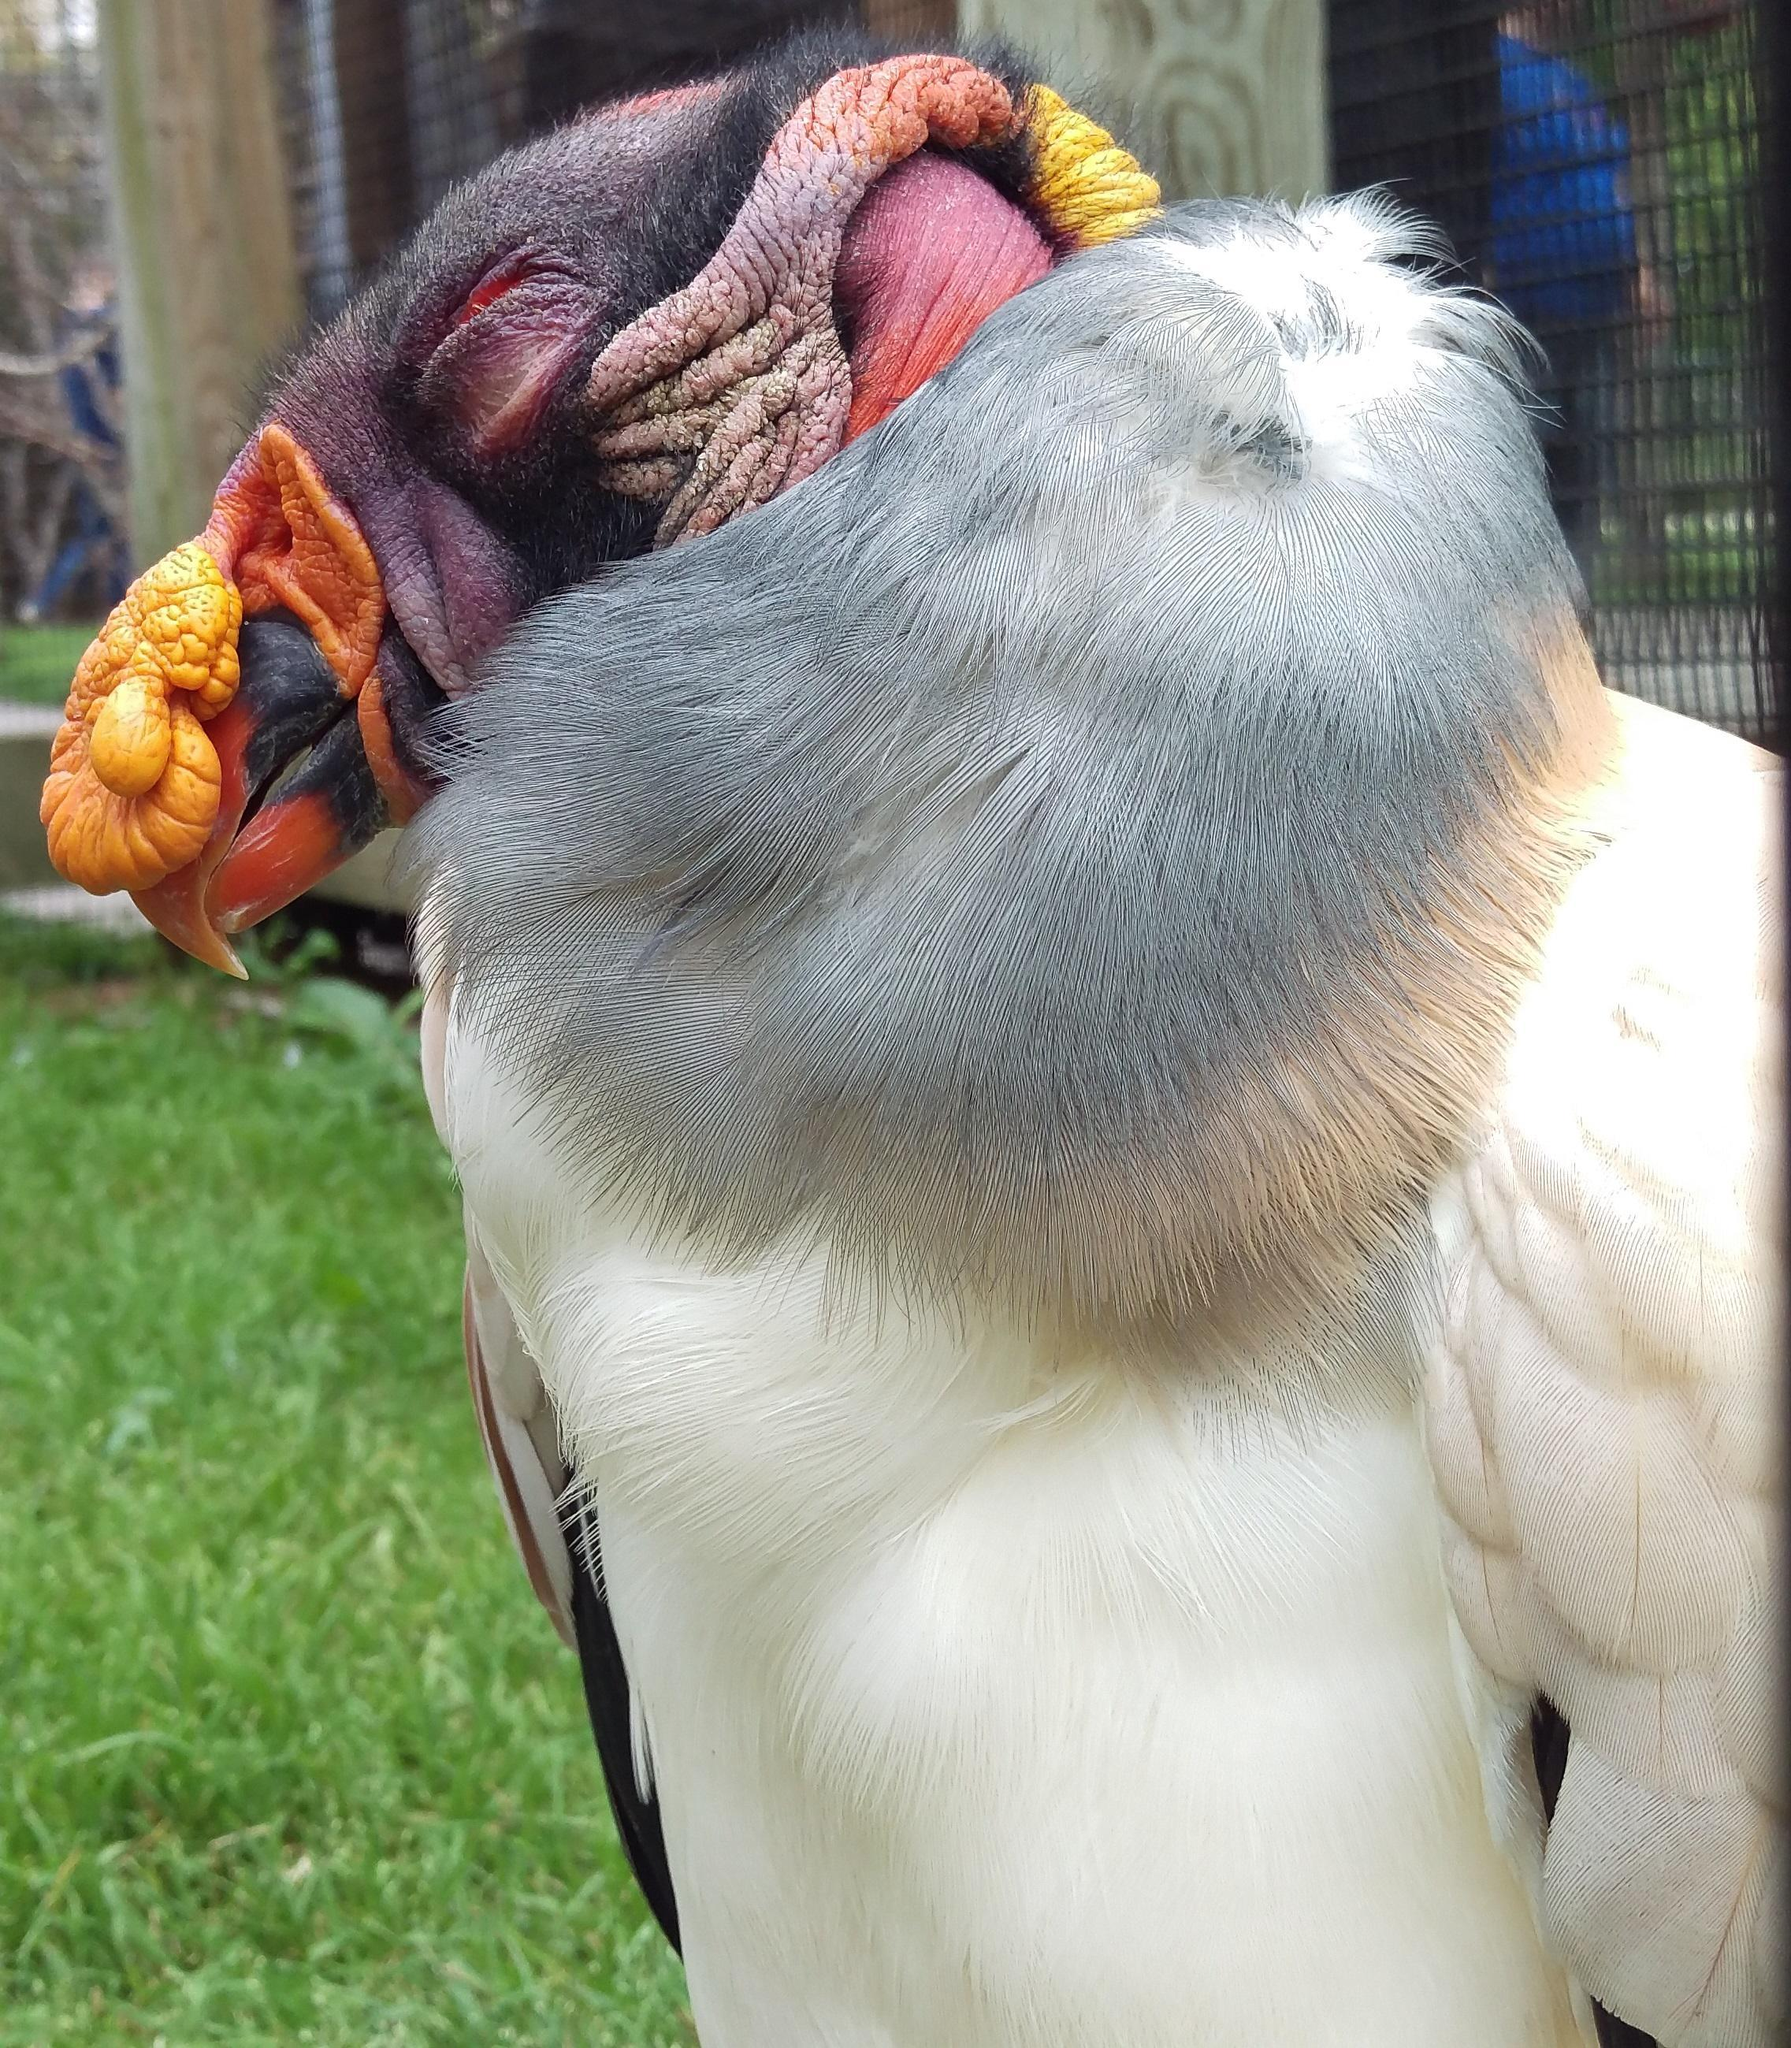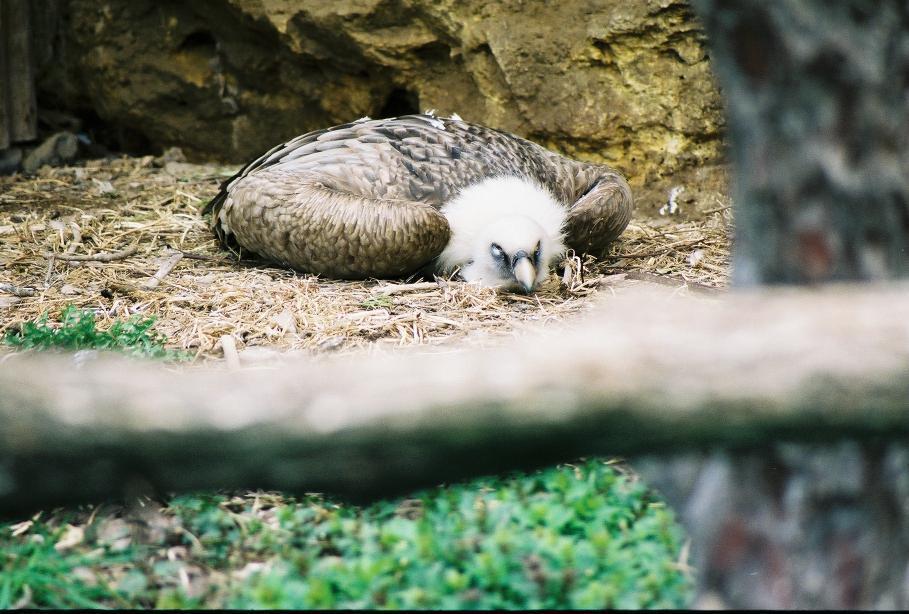The first image is the image on the left, the second image is the image on the right. Considering the images on both sides, is "An image shows one vulture with its white fuzzy-feathered head on the left of the picture." valid? Answer yes or no. No. The first image is the image on the left, the second image is the image on the right. For the images shown, is this caption "The bird in the image on the right is lying down." true? Answer yes or no. Yes. 